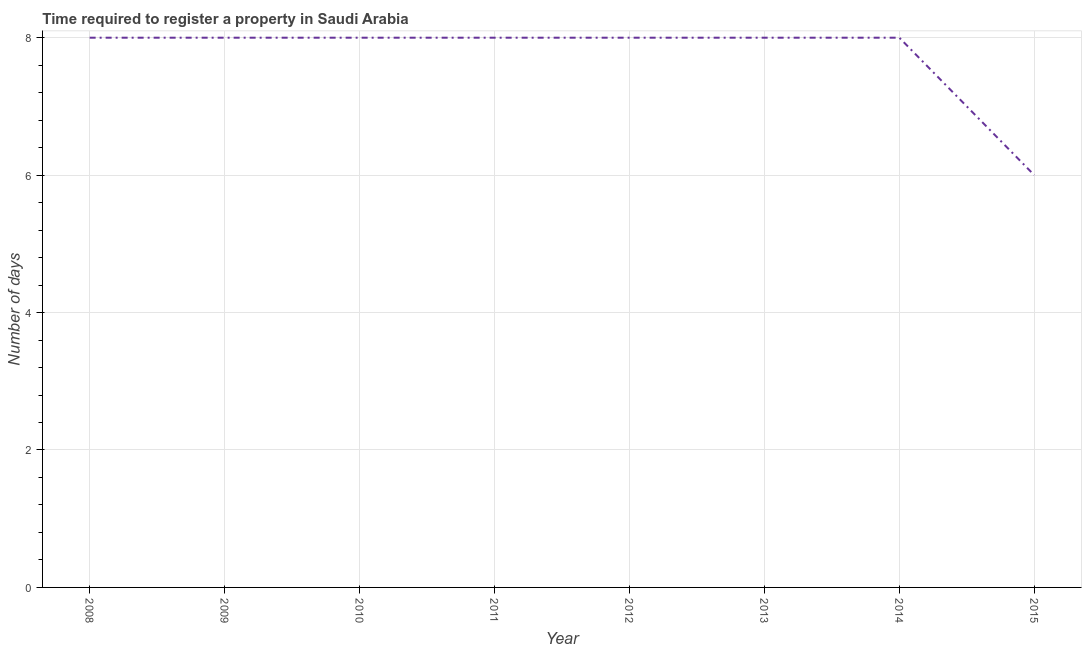What is the number of days required to register property in 2008?
Your response must be concise. 8. Across all years, what is the maximum number of days required to register property?
Offer a terse response. 8. Across all years, what is the minimum number of days required to register property?
Give a very brief answer. 6. In which year was the number of days required to register property minimum?
Give a very brief answer. 2015. What is the sum of the number of days required to register property?
Make the answer very short. 62. What is the average number of days required to register property per year?
Offer a very short reply. 7.75. What is the median number of days required to register property?
Keep it short and to the point. 8. What is the ratio of the number of days required to register property in 2012 to that in 2015?
Your answer should be compact. 1.33. Is the number of days required to register property in 2008 less than that in 2009?
Offer a very short reply. No. Is the difference between the number of days required to register property in 2012 and 2014 greater than the difference between any two years?
Offer a terse response. No. What is the difference between the highest and the second highest number of days required to register property?
Your answer should be very brief. 0. Is the sum of the number of days required to register property in 2009 and 2014 greater than the maximum number of days required to register property across all years?
Keep it short and to the point. Yes. What is the difference between the highest and the lowest number of days required to register property?
Provide a succinct answer. 2. In how many years, is the number of days required to register property greater than the average number of days required to register property taken over all years?
Make the answer very short. 7. How many lines are there?
Your answer should be compact. 1. How many years are there in the graph?
Ensure brevity in your answer.  8. What is the difference between two consecutive major ticks on the Y-axis?
Provide a short and direct response. 2. Are the values on the major ticks of Y-axis written in scientific E-notation?
Offer a terse response. No. Does the graph contain grids?
Give a very brief answer. Yes. What is the title of the graph?
Your answer should be compact. Time required to register a property in Saudi Arabia. What is the label or title of the Y-axis?
Provide a succinct answer. Number of days. What is the Number of days in 2013?
Give a very brief answer. 8. What is the Number of days in 2015?
Offer a terse response. 6. What is the difference between the Number of days in 2008 and 2011?
Offer a very short reply. 0. What is the difference between the Number of days in 2008 and 2014?
Provide a succinct answer. 0. What is the difference between the Number of days in 2009 and 2010?
Offer a terse response. 0. What is the difference between the Number of days in 2009 and 2011?
Your answer should be very brief. 0. What is the difference between the Number of days in 2009 and 2012?
Provide a short and direct response. 0. What is the difference between the Number of days in 2009 and 2013?
Make the answer very short. 0. What is the difference between the Number of days in 2009 and 2014?
Offer a terse response. 0. What is the difference between the Number of days in 2009 and 2015?
Keep it short and to the point. 2. What is the difference between the Number of days in 2010 and 2012?
Provide a short and direct response. 0. What is the difference between the Number of days in 2010 and 2014?
Ensure brevity in your answer.  0. What is the difference between the Number of days in 2010 and 2015?
Offer a very short reply. 2. What is the difference between the Number of days in 2011 and 2014?
Provide a short and direct response. 0. What is the difference between the Number of days in 2012 and 2014?
Make the answer very short. 0. What is the difference between the Number of days in 2014 and 2015?
Provide a short and direct response. 2. What is the ratio of the Number of days in 2008 to that in 2009?
Give a very brief answer. 1. What is the ratio of the Number of days in 2008 to that in 2011?
Offer a terse response. 1. What is the ratio of the Number of days in 2008 to that in 2014?
Ensure brevity in your answer.  1. What is the ratio of the Number of days in 2008 to that in 2015?
Offer a terse response. 1.33. What is the ratio of the Number of days in 2009 to that in 2013?
Keep it short and to the point. 1. What is the ratio of the Number of days in 2009 to that in 2015?
Give a very brief answer. 1.33. What is the ratio of the Number of days in 2010 to that in 2011?
Your response must be concise. 1. What is the ratio of the Number of days in 2010 to that in 2013?
Your answer should be very brief. 1. What is the ratio of the Number of days in 2010 to that in 2014?
Your answer should be very brief. 1. What is the ratio of the Number of days in 2010 to that in 2015?
Keep it short and to the point. 1.33. What is the ratio of the Number of days in 2011 to that in 2012?
Your answer should be compact. 1. What is the ratio of the Number of days in 2011 to that in 2013?
Provide a short and direct response. 1. What is the ratio of the Number of days in 2011 to that in 2015?
Keep it short and to the point. 1.33. What is the ratio of the Number of days in 2012 to that in 2013?
Provide a short and direct response. 1. What is the ratio of the Number of days in 2012 to that in 2015?
Offer a terse response. 1.33. What is the ratio of the Number of days in 2013 to that in 2014?
Provide a succinct answer. 1. What is the ratio of the Number of days in 2013 to that in 2015?
Keep it short and to the point. 1.33. What is the ratio of the Number of days in 2014 to that in 2015?
Give a very brief answer. 1.33. 